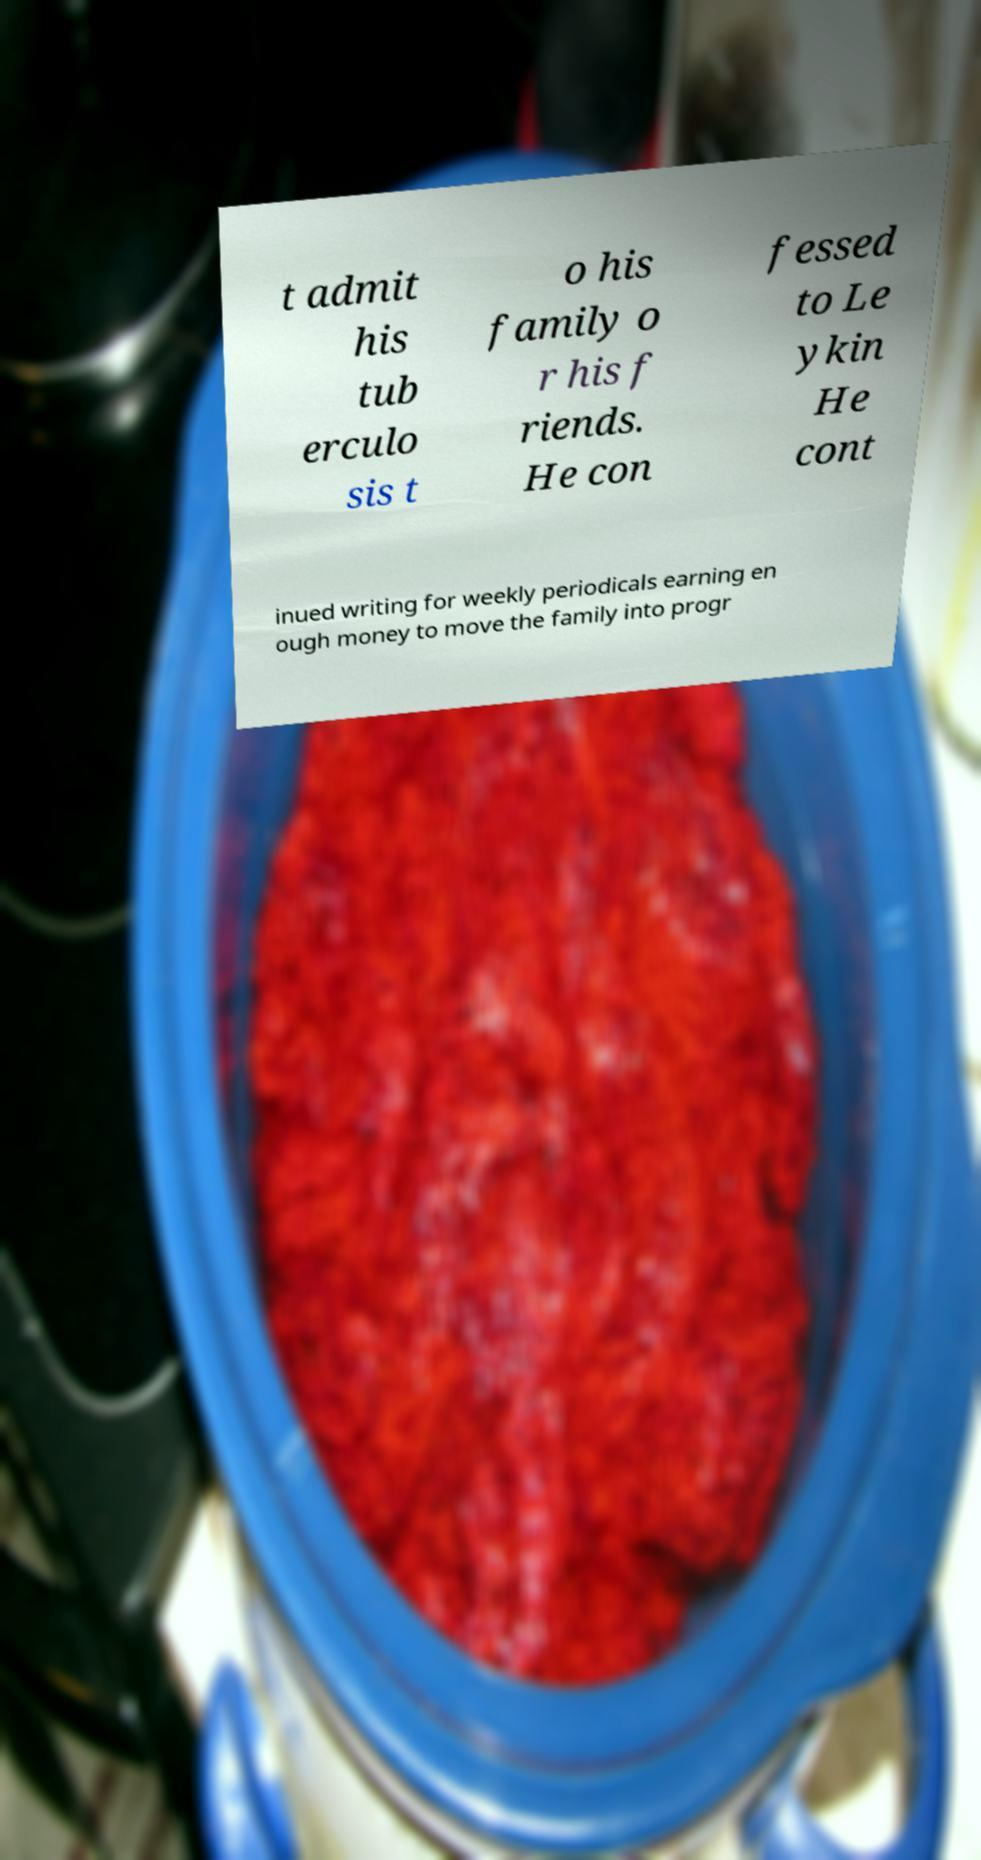For documentation purposes, I need the text within this image transcribed. Could you provide that? t admit his tub erculo sis t o his family o r his f riends. He con fessed to Le ykin He cont inued writing for weekly periodicals earning en ough money to move the family into progr 